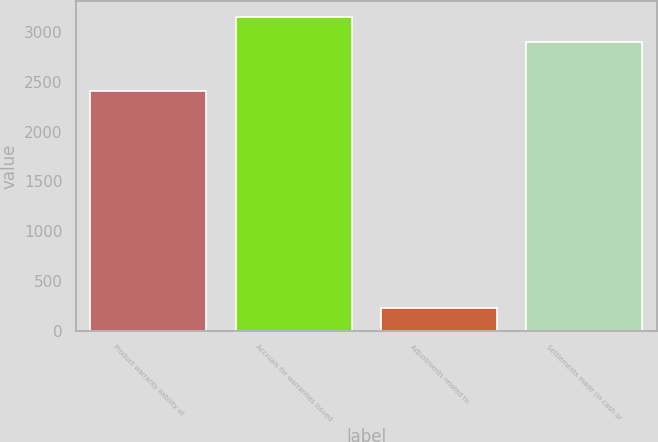Convert chart to OTSL. <chart><loc_0><loc_0><loc_500><loc_500><bar_chart><fcel>Product warranty liability at<fcel>Accruals for warranties issued<fcel>Adjustments related to<fcel>Settlements made (in cash or<nl><fcel>2409<fcel>3152.4<fcel>223<fcel>2904.6<nl></chart> 